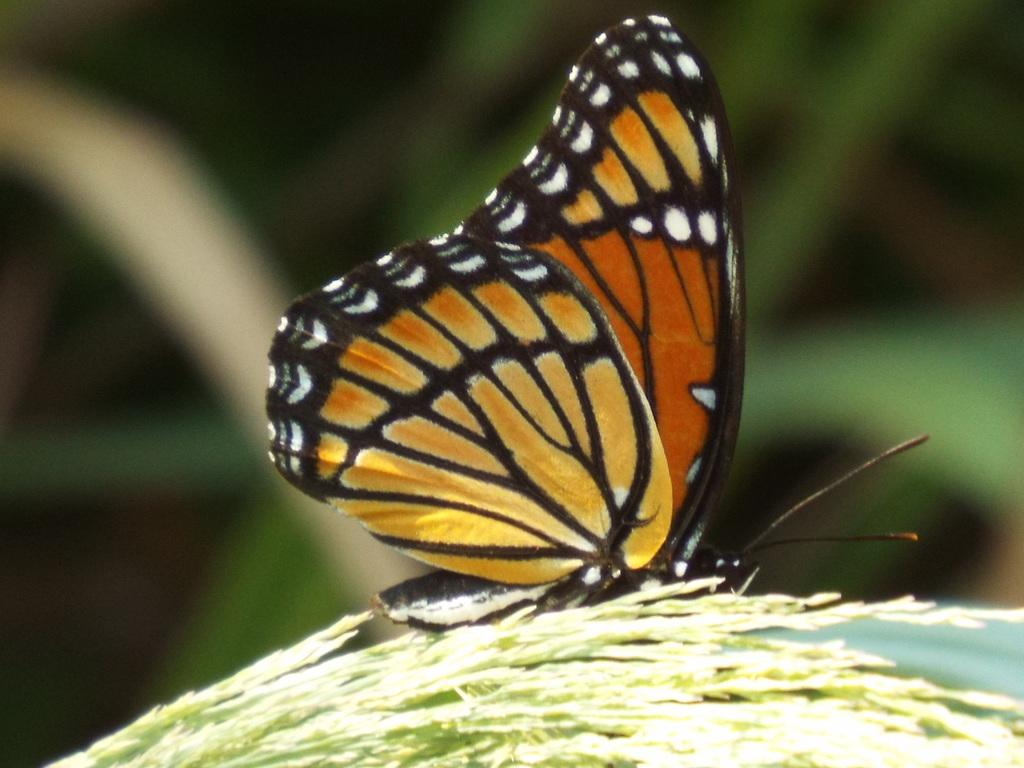What is the main subject of the picture? There is a butterfly in the picture. What can be seen at the bottom of the picture? There are leaves at the bottom of the picture. How would you describe the background of the image? The background of the image is blurry. Where is the lunchroom located in the picture? There is no lunchroom present in the picture; it features a butterfly and leaves. What type of shade is provided by the butterfly in the picture? There is no shade provided by the butterfly in the picture; it is a single butterfly and not a source of shade. 